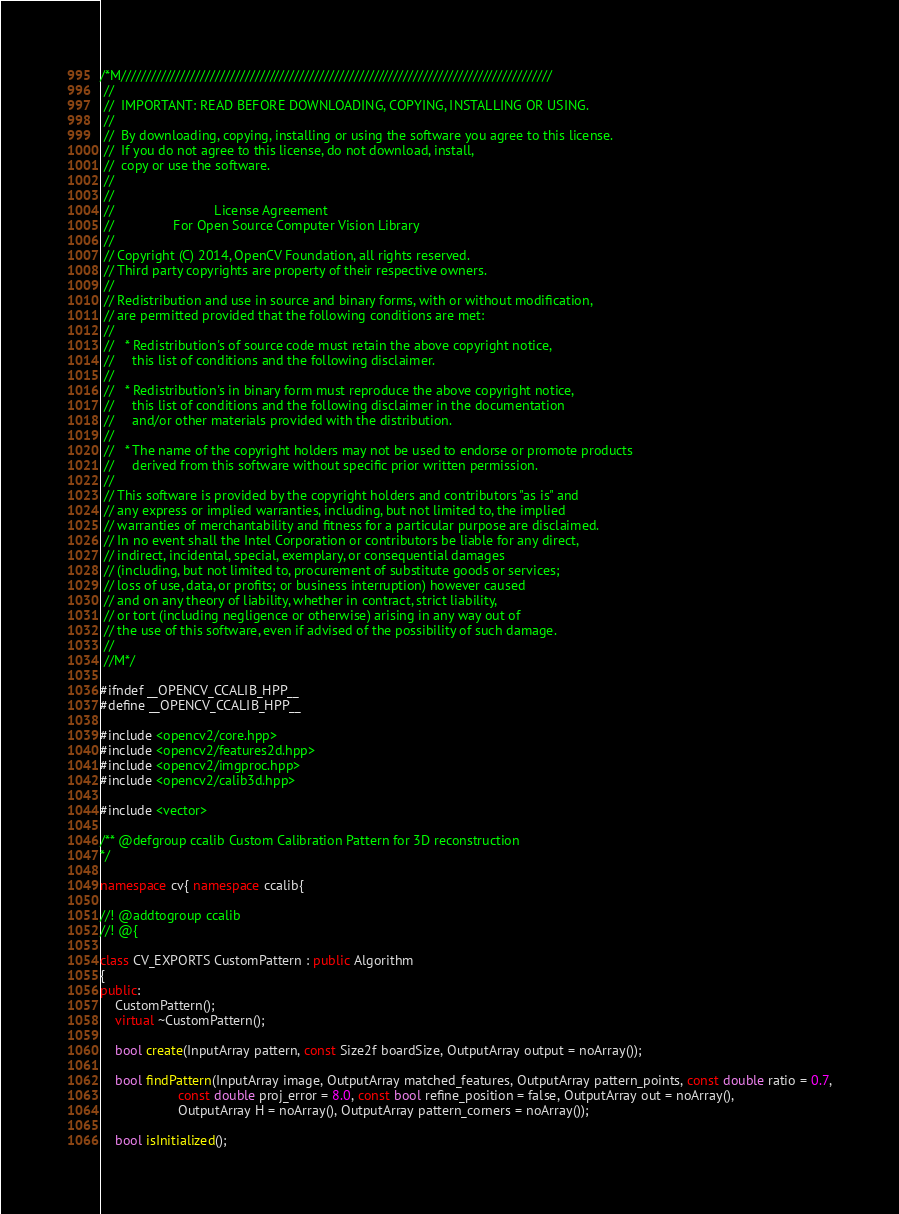Convert code to text. <code><loc_0><loc_0><loc_500><loc_500><_C++_>/*M///////////////////////////////////////////////////////////////////////////////////////
 //
 //  IMPORTANT: READ BEFORE DOWNLOADING, COPYING, INSTALLING OR USING.
 //
 //  By downloading, copying, installing or using the software you agree to this license.
 //  If you do not agree to this license, do not download, install,
 //  copy or use the software.
 //
 //
 //                           License Agreement
 //                For Open Source Computer Vision Library
 //
 // Copyright (C) 2014, OpenCV Foundation, all rights reserved.
 // Third party copyrights are property of their respective owners.
 //
 // Redistribution and use in source and binary forms, with or without modification,
 // are permitted provided that the following conditions are met:
 //
 //   * Redistribution's of source code must retain the above copyright notice,
 //     this list of conditions and the following disclaimer.
 //
 //   * Redistribution's in binary form must reproduce the above copyright notice,
 //     this list of conditions and the following disclaimer in the documentation
 //     and/or other materials provided with the distribution.
 //
 //   * The name of the copyright holders may not be used to endorse or promote products
 //     derived from this software without specific prior written permission.
 //
 // This software is provided by the copyright holders and contributors "as is" and
 // any express or implied warranties, including, but not limited to, the implied
 // warranties of merchantability and fitness for a particular purpose are disclaimed.
 // In no event shall the Intel Corporation or contributors be liable for any direct,
 // indirect, incidental, special, exemplary, or consequential damages
 // (including, but not limited to, procurement of substitute goods or services;
 // loss of use, data, or profits; or business interruption) however caused
 // and on any theory of liability, whether in contract, strict liability,
 // or tort (including negligence or otherwise) arising in any way out of
 // the use of this software, even if advised of the possibility of such damage.
 //
 //M*/

#ifndef __OPENCV_CCALIB_HPP__
#define __OPENCV_CCALIB_HPP__

#include <opencv2/core.hpp>
#include <opencv2/features2d.hpp>
#include <opencv2/imgproc.hpp>
#include <opencv2/calib3d.hpp>

#include <vector>

/** @defgroup ccalib Custom Calibration Pattern for 3D reconstruction
*/

namespace cv{ namespace ccalib{

//! @addtogroup ccalib
//! @{

class CV_EXPORTS CustomPattern : public Algorithm
{
public:
	CustomPattern();
	virtual ~CustomPattern();

	bool create(InputArray pattern, const Size2f boardSize, OutputArray output = noArray());

	bool findPattern(InputArray image, OutputArray matched_features, OutputArray pattern_points, const double ratio = 0.7,
					 const double proj_error = 8.0, const bool refine_position = false, OutputArray out = noArray(),
					 OutputArray H = noArray(), OutputArray pattern_corners = noArray());

	bool isInitialized();
</code> 